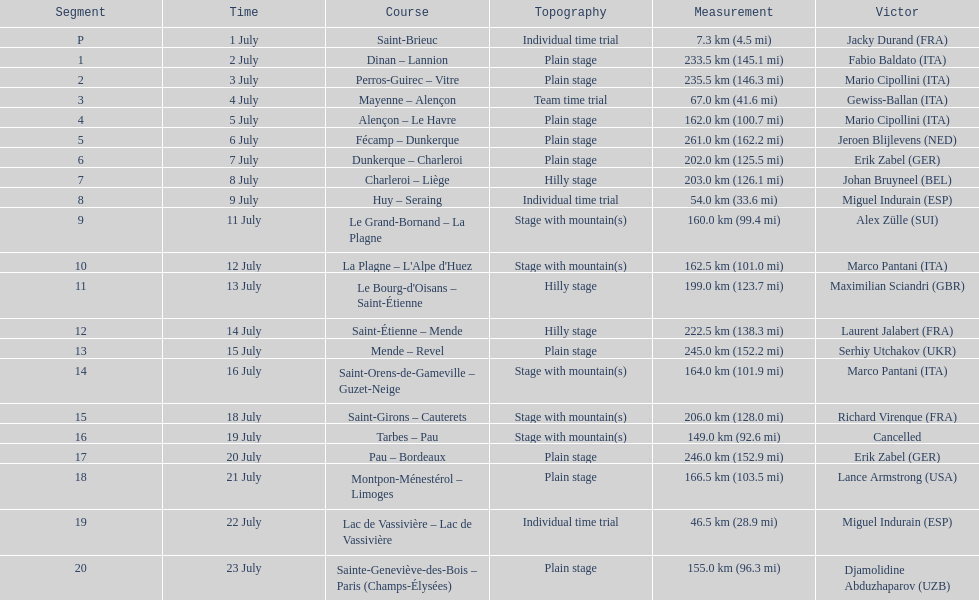How many routes have below 100 km total? 4. 